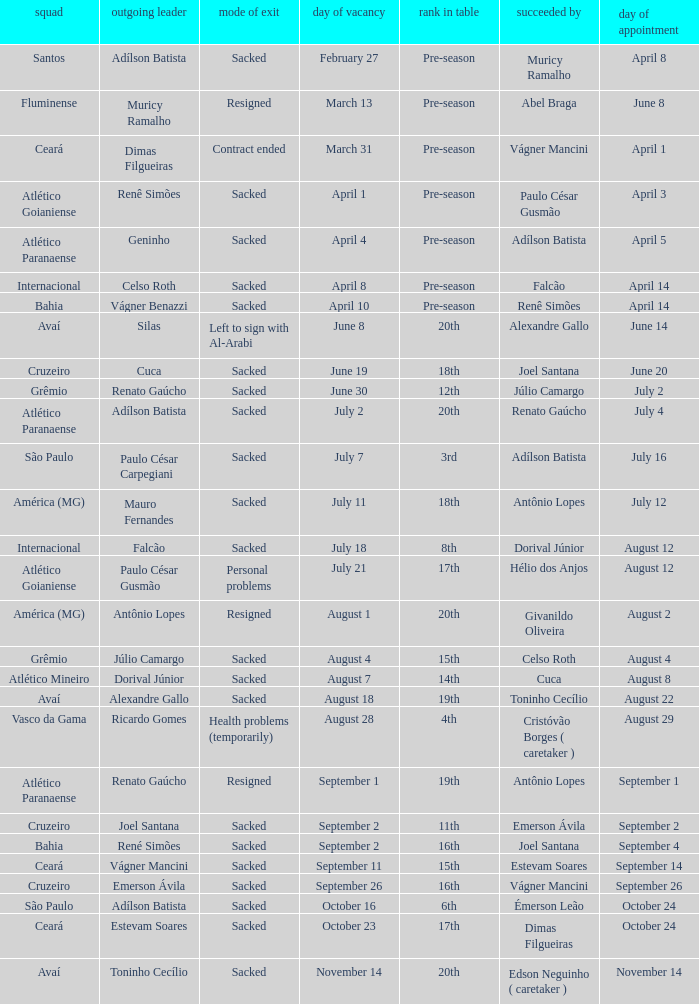Who was replaced as manager on June 20? Cuca. 